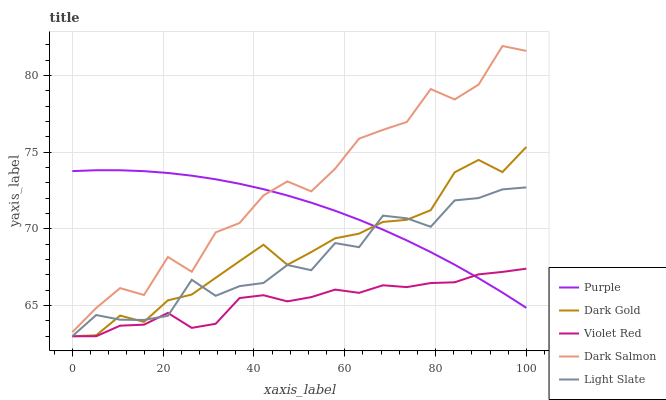Does Violet Red have the minimum area under the curve?
Answer yes or no. Yes. Does Dark Salmon have the maximum area under the curve?
Answer yes or no. Yes. Does Light Slate have the minimum area under the curve?
Answer yes or no. No. Does Light Slate have the maximum area under the curve?
Answer yes or no. No. Is Purple the smoothest?
Answer yes or no. Yes. Is Dark Salmon the roughest?
Answer yes or no. Yes. Is Light Slate the smoothest?
Answer yes or no. No. Is Light Slate the roughest?
Answer yes or no. No. Does Dark Salmon have the lowest value?
Answer yes or no. No. Does Dark Salmon have the highest value?
Answer yes or no. Yes. Does Light Slate have the highest value?
Answer yes or no. No. Is Light Slate less than Dark Salmon?
Answer yes or no. Yes. Is Dark Salmon greater than Light Slate?
Answer yes or no. Yes. Does Light Slate intersect Dark Salmon?
Answer yes or no. No. 